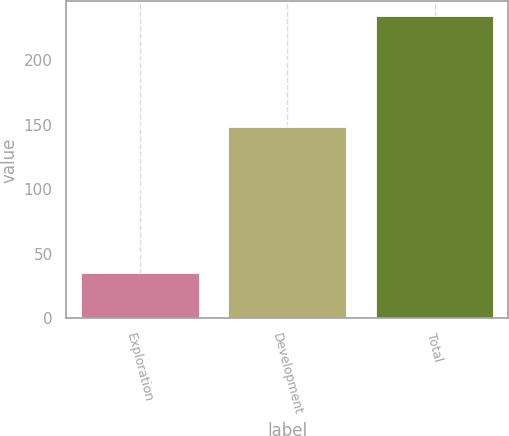Convert chart to OTSL. <chart><loc_0><loc_0><loc_500><loc_500><bar_chart><fcel>Exploration<fcel>Development<fcel>Total<nl><fcel>35<fcel>148<fcel>234<nl></chart> 